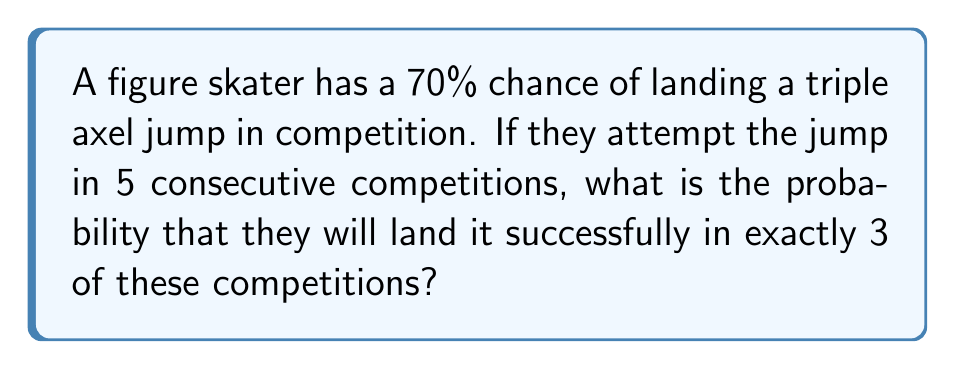Solve this math problem. To solve this problem, we'll use the Bernoulli process and the binomial probability formula:

1) Let's define our variables:
   $p = 0.7$ (probability of success)
   $q = 1 - p = 0.3$ (probability of failure)
   $n = 5$ (number of trials)
   $k = 3$ (number of successes we're interested in)

2) The binomial probability formula is:

   $$P(X = k) = \binom{n}{k} p^k q^{n-k}$$

3) Let's calculate each part:
   
   $\binom{n}{k} = \binom{5}{3} = \frac{5!}{3!(5-3)!} = \frac{5 \cdot 4}{2 \cdot 1} = 10$

   $p^k = 0.7^3 = 0.343$

   $q^{n-k} = 0.3^2 = 0.09$

4) Now, let's put it all together:

   $$P(X = 3) = 10 \cdot 0.343 \cdot 0.09 = 0.3087$$

5) Therefore, the probability of landing the triple axel in exactly 3 out of 5 competitions is approximately 0.3087 or 30.87%.
Answer: 0.3087 